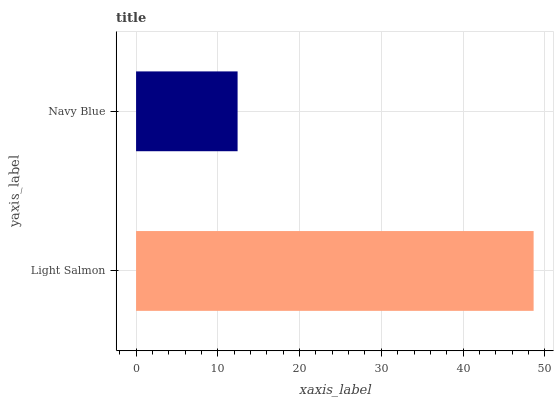Is Navy Blue the minimum?
Answer yes or no. Yes. Is Light Salmon the maximum?
Answer yes or no. Yes. Is Navy Blue the maximum?
Answer yes or no. No. Is Light Salmon greater than Navy Blue?
Answer yes or no. Yes. Is Navy Blue less than Light Salmon?
Answer yes or no. Yes. Is Navy Blue greater than Light Salmon?
Answer yes or no. No. Is Light Salmon less than Navy Blue?
Answer yes or no. No. Is Light Salmon the high median?
Answer yes or no. Yes. Is Navy Blue the low median?
Answer yes or no. Yes. Is Navy Blue the high median?
Answer yes or no. No. Is Light Salmon the low median?
Answer yes or no. No. 